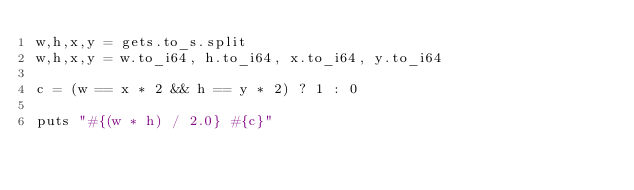<code> <loc_0><loc_0><loc_500><loc_500><_Crystal_>w,h,x,y = gets.to_s.split
w,h,x,y = w.to_i64, h.to_i64, x.to_i64, y.to_i64

c = (w == x * 2 && h == y * 2) ? 1 : 0

puts "#{(w * h) / 2.0} #{c}"</code> 